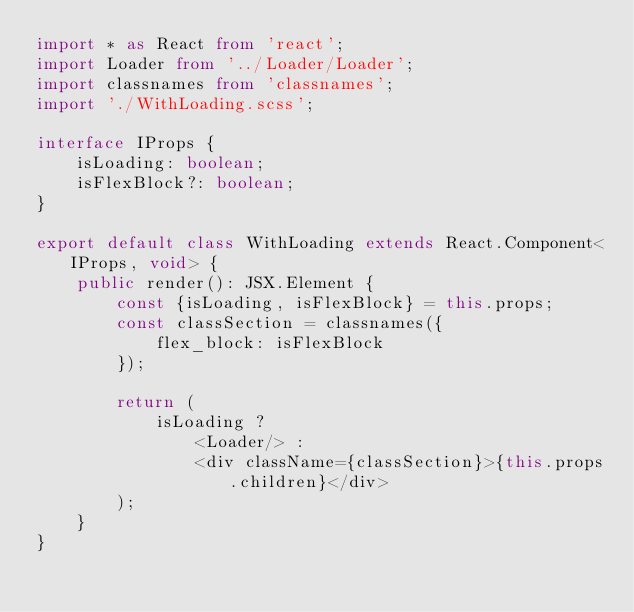Convert code to text. <code><loc_0><loc_0><loc_500><loc_500><_TypeScript_>import * as React from 'react';
import Loader from '../Loader/Loader';
import classnames from 'classnames';
import './WithLoading.scss';

interface IProps {
    isLoading: boolean;
    isFlexBlock?: boolean;
}

export default class WithLoading extends React.Component<IProps, void> {
    public render(): JSX.Element {
        const {isLoading, isFlexBlock} = this.props;
        const classSection = classnames({
            flex_block: isFlexBlock
        });

        return (
            isLoading ?
                <Loader/> :
                <div className={classSection}>{this.props.children}</div>
        );
    }
}
</code> 